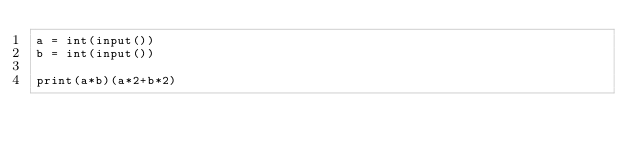Convert code to text. <code><loc_0><loc_0><loc_500><loc_500><_Python_>a = int(input())
b = int(input())

print(a*b)(a*2+b*2)</code> 